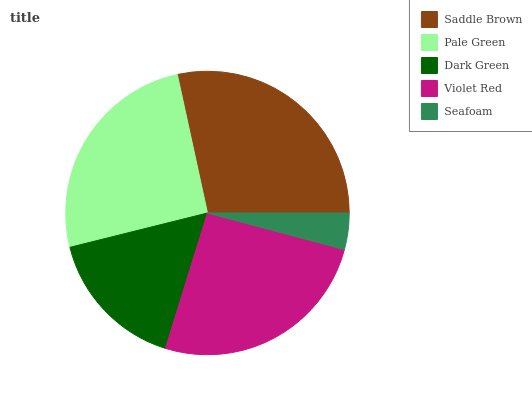Is Seafoam the minimum?
Answer yes or no. Yes. Is Saddle Brown the maximum?
Answer yes or no. Yes. Is Pale Green the minimum?
Answer yes or no. No. Is Pale Green the maximum?
Answer yes or no. No. Is Saddle Brown greater than Pale Green?
Answer yes or no. Yes. Is Pale Green less than Saddle Brown?
Answer yes or no. Yes. Is Pale Green greater than Saddle Brown?
Answer yes or no. No. Is Saddle Brown less than Pale Green?
Answer yes or no. No. Is Pale Green the high median?
Answer yes or no. Yes. Is Pale Green the low median?
Answer yes or no. Yes. Is Dark Green the high median?
Answer yes or no. No. Is Violet Red the low median?
Answer yes or no. No. 